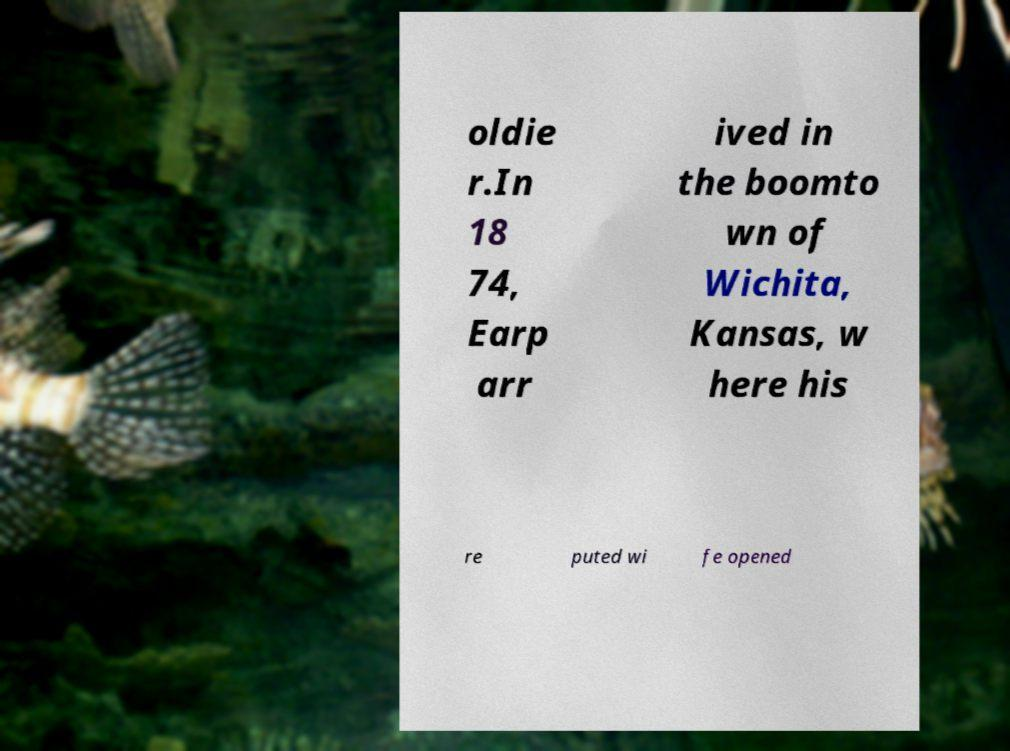Could you assist in decoding the text presented in this image and type it out clearly? oldie r.In 18 74, Earp arr ived in the boomto wn of Wichita, Kansas, w here his re puted wi fe opened 